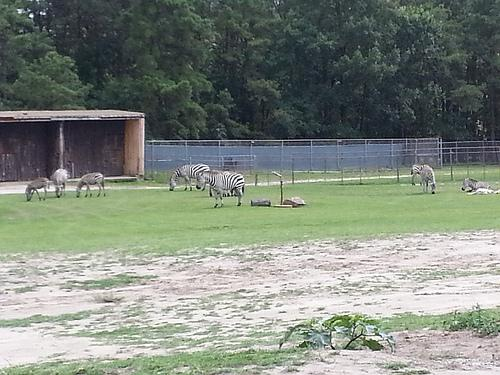Question: what colors are the animals in this picture?
Choices:
A. Reddish.
B. White and tan.
C. Black and white.
D. Brown.
Answer with the letter. Answer: C Question: what color are the trees in the background?
Choices:
A. Brown.
B. Red.
C. Yellow.
D. Green.
Answer with the letter. Answer: D Question: how many people appear in this picture?
Choices:
A. Zero.
B. One.
C. Two.
D. Six.
Answer with the letter. Answer: A 